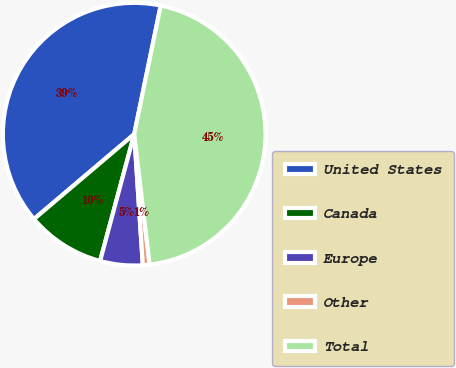Convert chart to OTSL. <chart><loc_0><loc_0><loc_500><loc_500><pie_chart><fcel>United States<fcel>Canada<fcel>Europe<fcel>Other<fcel>Total<nl><fcel>39.42%<fcel>9.63%<fcel>5.23%<fcel>0.82%<fcel>44.9%<nl></chart> 